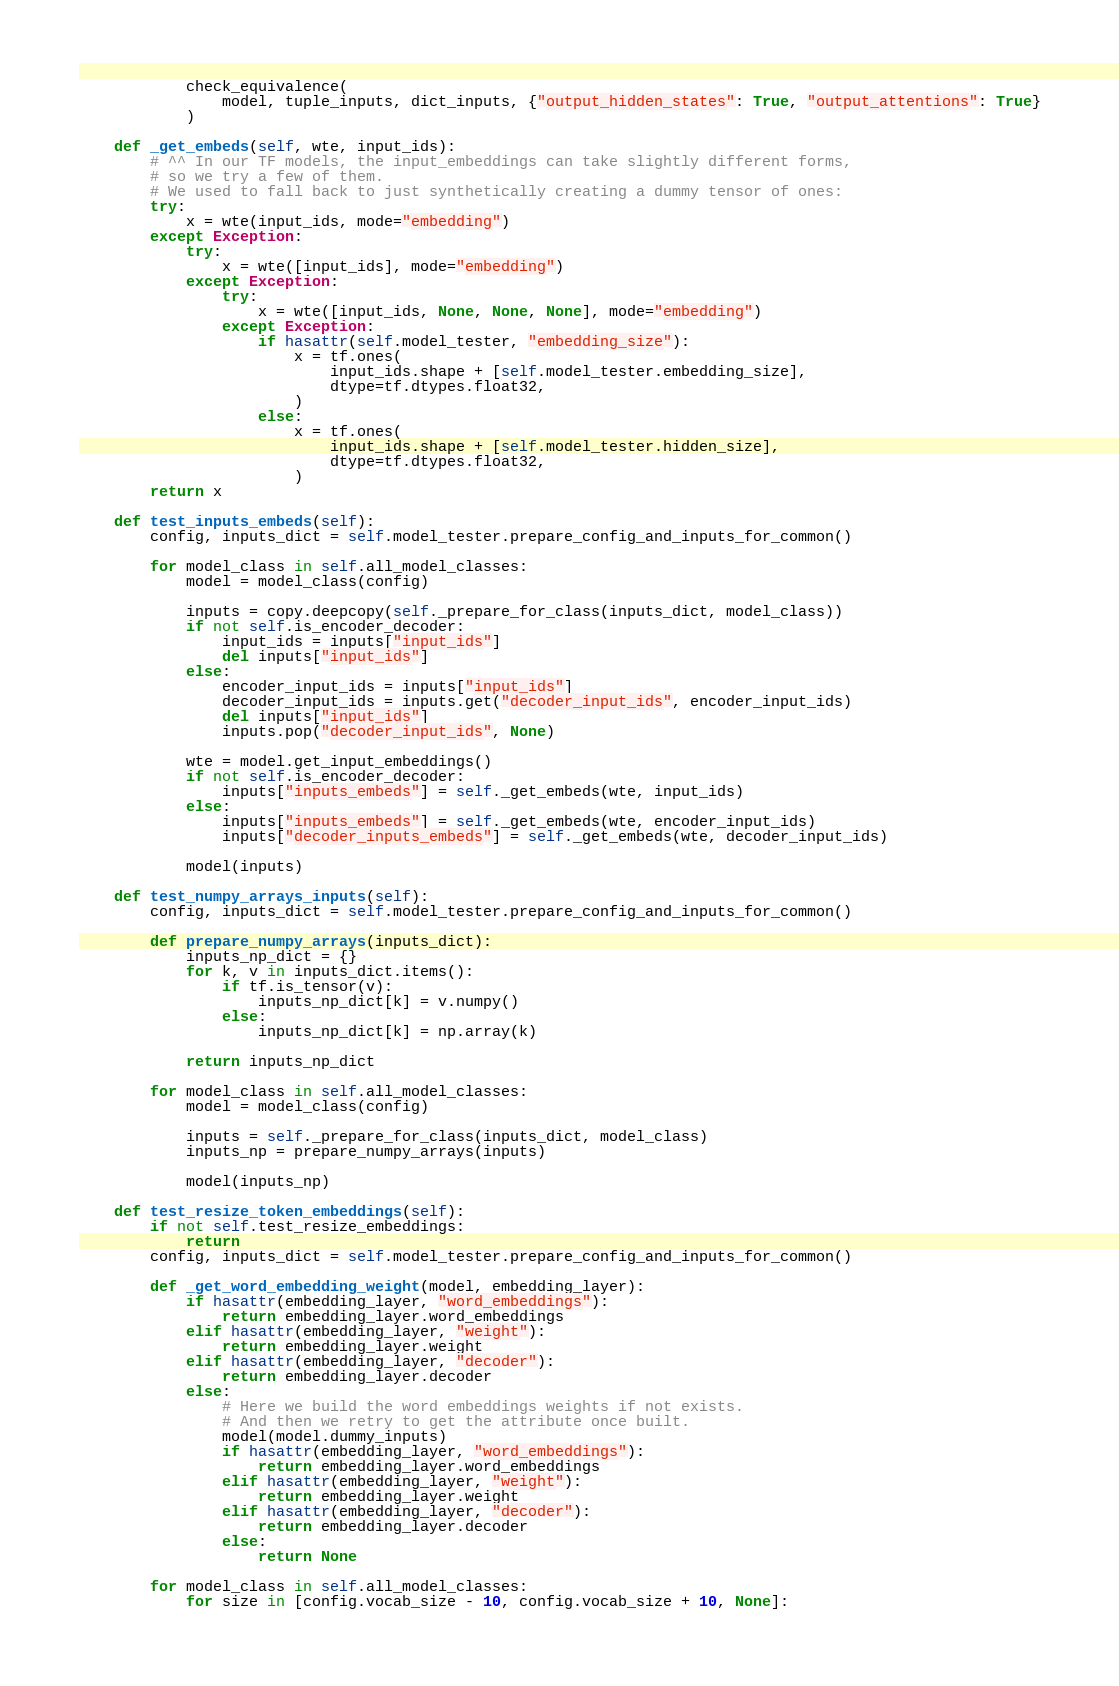<code> <loc_0><loc_0><loc_500><loc_500><_Python_>            check_equivalence(
                model, tuple_inputs, dict_inputs, {"output_hidden_states": True, "output_attentions": True}
            )

    def _get_embeds(self, wte, input_ids):
        # ^^ In our TF models, the input_embeddings can take slightly different forms,
        # so we try a few of them.
        # We used to fall back to just synthetically creating a dummy tensor of ones:
        try:
            x = wte(input_ids, mode="embedding")
        except Exception:
            try:
                x = wte([input_ids], mode="embedding")
            except Exception:
                try:
                    x = wte([input_ids, None, None, None], mode="embedding")
                except Exception:
                    if hasattr(self.model_tester, "embedding_size"):
                        x = tf.ones(
                            input_ids.shape + [self.model_tester.embedding_size],
                            dtype=tf.dtypes.float32,
                        )
                    else:
                        x = tf.ones(
                            input_ids.shape + [self.model_tester.hidden_size],
                            dtype=tf.dtypes.float32,
                        )
        return x

    def test_inputs_embeds(self):
        config, inputs_dict = self.model_tester.prepare_config_and_inputs_for_common()

        for model_class in self.all_model_classes:
            model = model_class(config)

            inputs = copy.deepcopy(self._prepare_for_class(inputs_dict, model_class))
            if not self.is_encoder_decoder:
                input_ids = inputs["input_ids"]
                del inputs["input_ids"]
            else:
                encoder_input_ids = inputs["input_ids"]
                decoder_input_ids = inputs.get("decoder_input_ids", encoder_input_ids)
                del inputs["input_ids"]
                inputs.pop("decoder_input_ids", None)

            wte = model.get_input_embeddings()
            if not self.is_encoder_decoder:
                inputs["inputs_embeds"] = self._get_embeds(wte, input_ids)
            else:
                inputs["inputs_embeds"] = self._get_embeds(wte, encoder_input_ids)
                inputs["decoder_inputs_embeds"] = self._get_embeds(wte, decoder_input_ids)

            model(inputs)

    def test_numpy_arrays_inputs(self):
        config, inputs_dict = self.model_tester.prepare_config_and_inputs_for_common()

        def prepare_numpy_arrays(inputs_dict):
            inputs_np_dict = {}
            for k, v in inputs_dict.items():
                if tf.is_tensor(v):
                    inputs_np_dict[k] = v.numpy()
                else:
                    inputs_np_dict[k] = np.array(k)

            return inputs_np_dict

        for model_class in self.all_model_classes:
            model = model_class(config)

            inputs = self._prepare_for_class(inputs_dict, model_class)
            inputs_np = prepare_numpy_arrays(inputs)

            model(inputs_np)

    def test_resize_token_embeddings(self):
        if not self.test_resize_embeddings:
            return
        config, inputs_dict = self.model_tester.prepare_config_and_inputs_for_common()

        def _get_word_embedding_weight(model, embedding_layer):
            if hasattr(embedding_layer, "word_embeddings"):
                return embedding_layer.word_embeddings
            elif hasattr(embedding_layer, "weight"):
                return embedding_layer.weight
            elif hasattr(embedding_layer, "decoder"):
                return embedding_layer.decoder
            else:
                # Here we build the word embeddings weights if not exists.
                # And then we retry to get the attribute once built.
                model(model.dummy_inputs)
                if hasattr(embedding_layer, "word_embeddings"):
                    return embedding_layer.word_embeddings
                elif hasattr(embedding_layer, "weight"):
                    return embedding_layer.weight
                elif hasattr(embedding_layer, "decoder"):
                    return embedding_layer.decoder
                else:
                    return None

        for model_class in self.all_model_classes:
            for size in [config.vocab_size - 10, config.vocab_size + 10, None]:</code> 